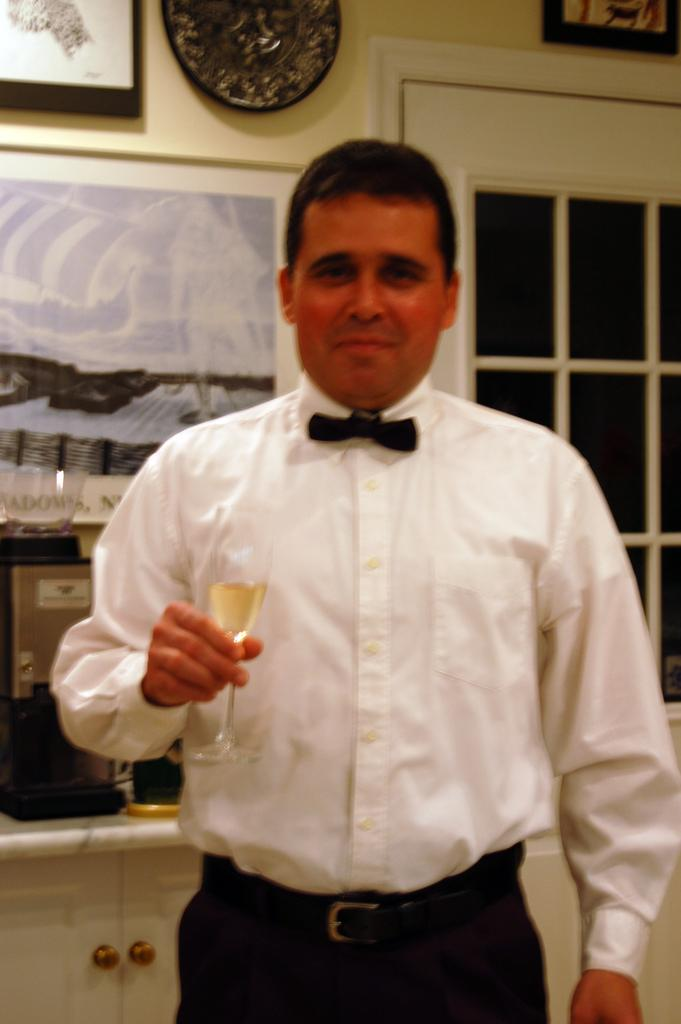Who is present in the image? There is a man in the image. What is the man holding in the image? The man is holding a wine glass. Can you describe the man's clothing in the image? The man is wearing a white shirt and black pants. What can be seen in the background of the image? There is a wall, photo frames, and a window in the background of the image. How many books can be seen on the man's elbow in the image? There are no books visible on the man's elbow in the image. 